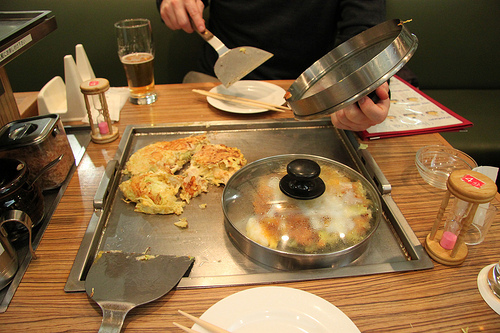<image>
Is the food in the lid? No. The food is not contained within the lid. These objects have a different spatial relationship. 